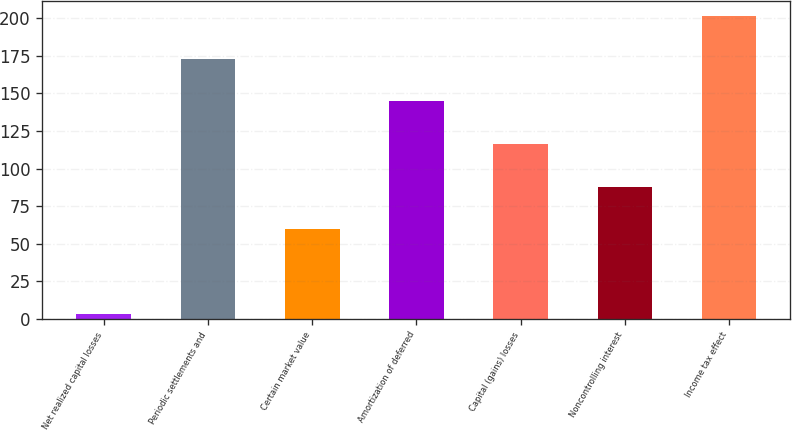<chart> <loc_0><loc_0><loc_500><loc_500><bar_chart><fcel>Net realized capital losses<fcel>Periodic settlements and<fcel>Certain market value<fcel>Amortization of deferred<fcel>Capital (gains) losses<fcel>Noncontrolling interest<fcel>Income tax effect<nl><fcel>3<fcel>173.04<fcel>59.68<fcel>144.7<fcel>116.36<fcel>88.02<fcel>201.38<nl></chart> 